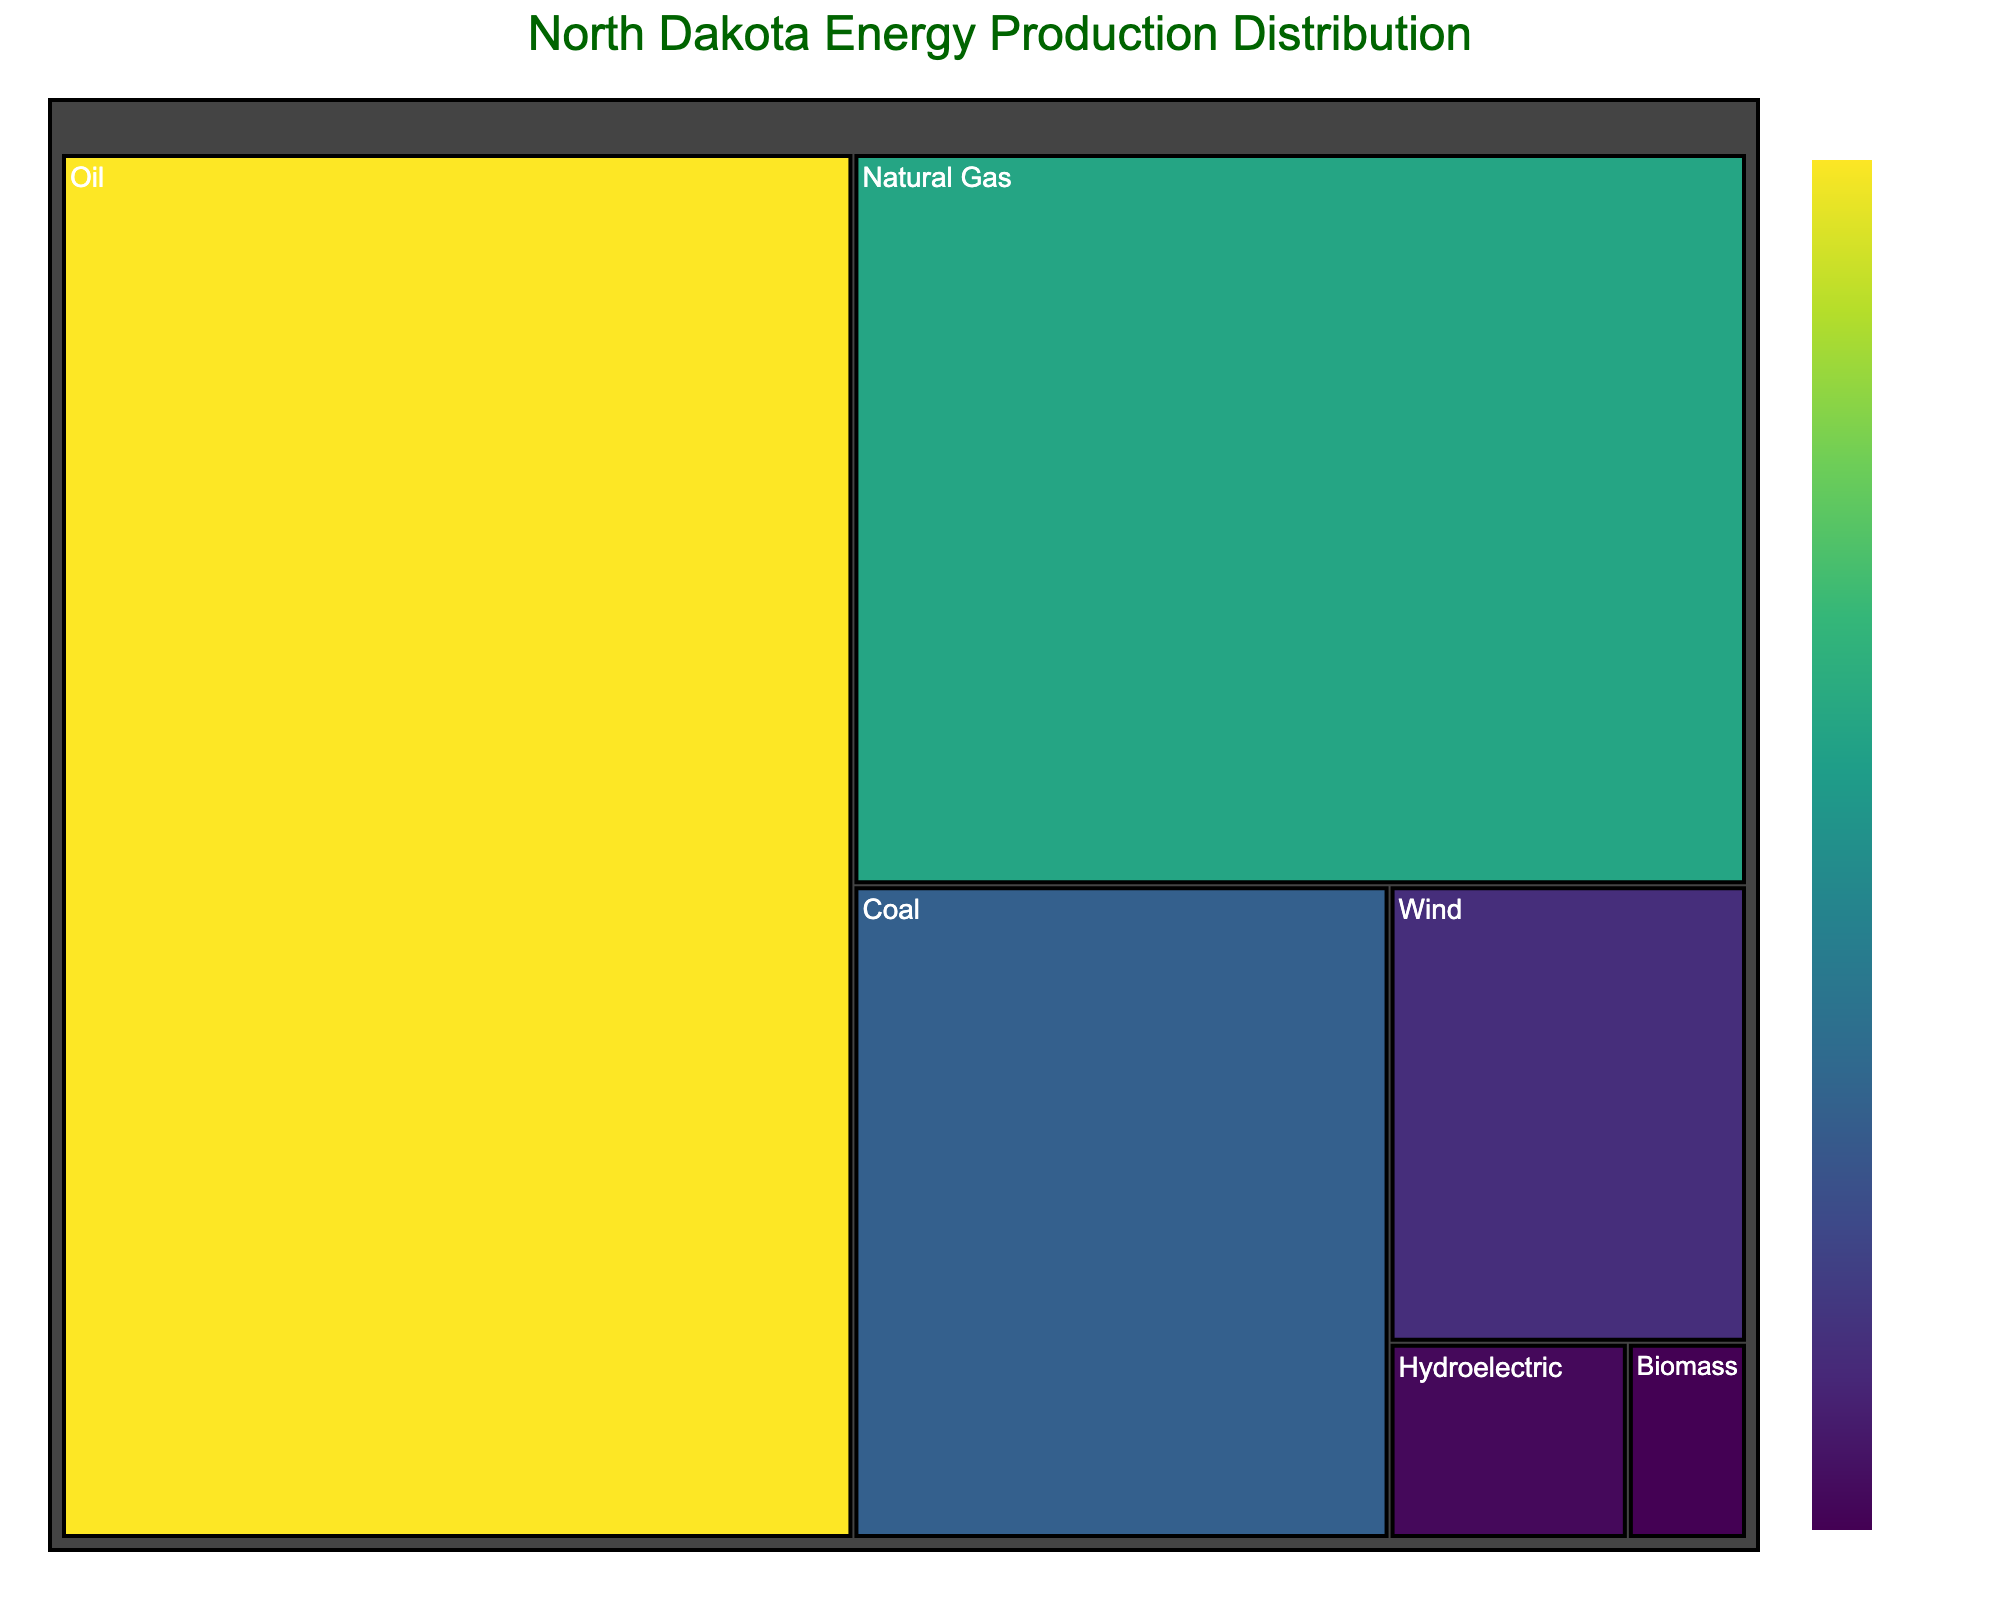Which energy source has the largest share? Look for the energy source with the highest percentage value in the treemap. Oil has the highest percentage at 47%.
Answer: Oil What is the percentage of wind energy production? Find the section labeled "Wind" and read the percentage value. It is 7%.
Answer: 7% What is the combined percentage of renewable energy sources (Wind, Hydroelectric, Biomass)? Add the percentages of Wind (7%), Hydroelectric (2%), and Biomass (1%). 7 + 2 + 1 = 10%.
Answer: 10% Which energy source has the smallest share in North Dakota's energy production? Identify the section with the smallest percentage value in the treemap. Biomass is the smallest at 1%.
Answer: Biomass Is the percentage of Natural Gas production greater than the percentage of Coal production? Compare the percentages of Natural Gas (28%) and Coal (15%). 28% is greater than 15%.
Answer: Yes How much more is the percentage of Oil production compared to Coal production? Subtract the percentage of Coal from the percentage of Oil. 47% - 15% = 32%.
Answer: 32% What is the color range used in the treemap to represent different percentages? Look at the color gradient in the treemap, which uses a viridis color scale. It ranges from dark colors (low percentages) to bright colors (high percentages).
Answer: viridis What is the title of the treemap? Read the text at the top of the treemap to find the title. The title is "North Dakota Energy Production Distribution".
Answer: North Dakota Energy Production Distribution Which energy sources have a percentage below 10%? Identify sections in the treemap with percentages under 10%. They are Wind (7%), Hydroelectric (2%), and Biomass (1%).
Answer: Wind, Hydroelectric, Biomass What percentage of energy production is contributed by fossil fuels (Oil, Natural Gas, Coal)? Add the percentages of Oil (47%), Natural Gas (28%), and Coal (15%). 47 + 28 + 15 = 90%.
Answer: 90% 